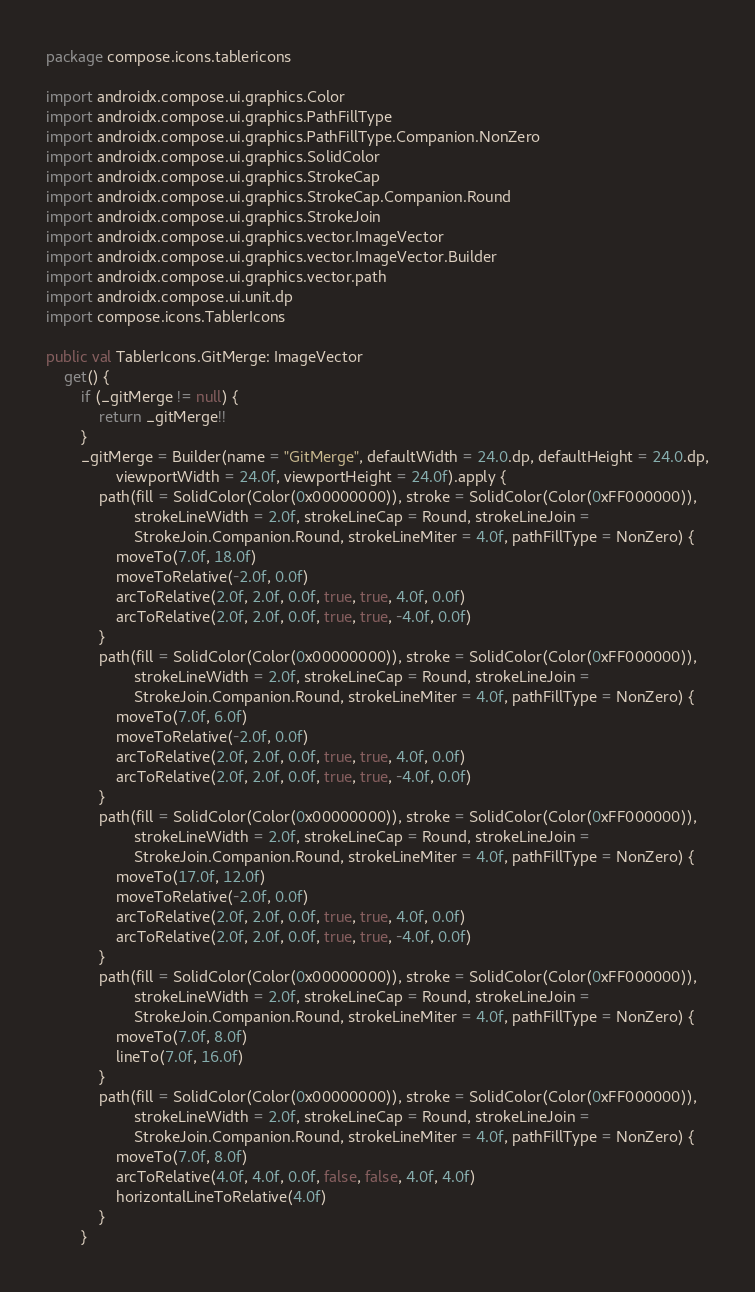Convert code to text. <code><loc_0><loc_0><loc_500><loc_500><_Kotlin_>package compose.icons.tablericons

import androidx.compose.ui.graphics.Color
import androidx.compose.ui.graphics.PathFillType
import androidx.compose.ui.graphics.PathFillType.Companion.NonZero
import androidx.compose.ui.graphics.SolidColor
import androidx.compose.ui.graphics.StrokeCap
import androidx.compose.ui.graphics.StrokeCap.Companion.Round
import androidx.compose.ui.graphics.StrokeJoin
import androidx.compose.ui.graphics.vector.ImageVector
import androidx.compose.ui.graphics.vector.ImageVector.Builder
import androidx.compose.ui.graphics.vector.path
import androidx.compose.ui.unit.dp
import compose.icons.TablerIcons

public val TablerIcons.GitMerge: ImageVector
    get() {
        if (_gitMerge != null) {
            return _gitMerge!!
        }
        _gitMerge = Builder(name = "GitMerge", defaultWidth = 24.0.dp, defaultHeight = 24.0.dp,
                viewportWidth = 24.0f, viewportHeight = 24.0f).apply {
            path(fill = SolidColor(Color(0x00000000)), stroke = SolidColor(Color(0xFF000000)),
                    strokeLineWidth = 2.0f, strokeLineCap = Round, strokeLineJoin =
                    StrokeJoin.Companion.Round, strokeLineMiter = 4.0f, pathFillType = NonZero) {
                moveTo(7.0f, 18.0f)
                moveToRelative(-2.0f, 0.0f)
                arcToRelative(2.0f, 2.0f, 0.0f, true, true, 4.0f, 0.0f)
                arcToRelative(2.0f, 2.0f, 0.0f, true, true, -4.0f, 0.0f)
            }
            path(fill = SolidColor(Color(0x00000000)), stroke = SolidColor(Color(0xFF000000)),
                    strokeLineWidth = 2.0f, strokeLineCap = Round, strokeLineJoin =
                    StrokeJoin.Companion.Round, strokeLineMiter = 4.0f, pathFillType = NonZero) {
                moveTo(7.0f, 6.0f)
                moveToRelative(-2.0f, 0.0f)
                arcToRelative(2.0f, 2.0f, 0.0f, true, true, 4.0f, 0.0f)
                arcToRelative(2.0f, 2.0f, 0.0f, true, true, -4.0f, 0.0f)
            }
            path(fill = SolidColor(Color(0x00000000)), stroke = SolidColor(Color(0xFF000000)),
                    strokeLineWidth = 2.0f, strokeLineCap = Round, strokeLineJoin =
                    StrokeJoin.Companion.Round, strokeLineMiter = 4.0f, pathFillType = NonZero) {
                moveTo(17.0f, 12.0f)
                moveToRelative(-2.0f, 0.0f)
                arcToRelative(2.0f, 2.0f, 0.0f, true, true, 4.0f, 0.0f)
                arcToRelative(2.0f, 2.0f, 0.0f, true, true, -4.0f, 0.0f)
            }
            path(fill = SolidColor(Color(0x00000000)), stroke = SolidColor(Color(0xFF000000)),
                    strokeLineWidth = 2.0f, strokeLineCap = Round, strokeLineJoin =
                    StrokeJoin.Companion.Round, strokeLineMiter = 4.0f, pathFillType = NonZero) {
                moveTo(7.0f, 8.0f)
                lineTo(7.0f, 16.0f)
            }
            path(fill = SolidColor(Color(0x00000000)), stroke = SolidColor(Color(0xFF000000)),
                    strokeLineWidth = 2.0f, strokeLineCap = Round, strokeLineJoin =
                    StrokeJoin.Companion.Round, strokeLineMiter = 4.0f, pathFillType = NonZero) {
                moveTo(7.0f, 8.0f)
                arcToRelative(4.0f, 4.0f, 0.0f, false, false, 4.0f, 4.0f)
                horizontalLineToRelative(4.0f)
            }
        }</code> 